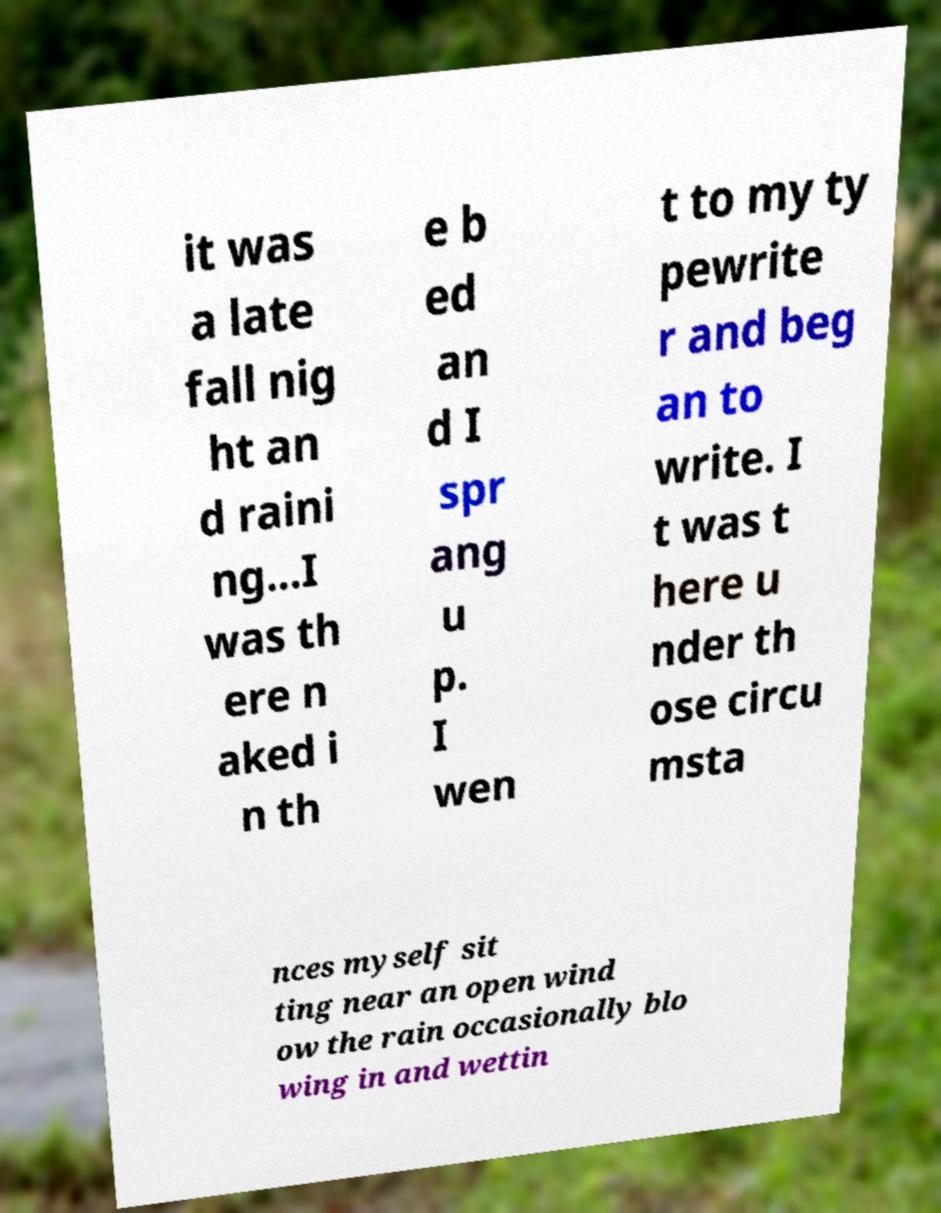What messages or text are displayed in this image? I need them in a readable, typed format. it was a late fall nig ht an d raini ng...I was th ere n aked i n th e b ed an d I spr ang u p. I wen t to my ty pewrite r and beg an to write. I t was t here u nder th ose circu msta nces myself sit ting near an open wind ow the rain occasionally blo wing in and wettin 